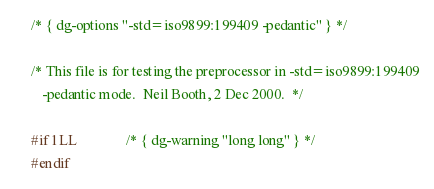Convert code to text. <code><loc_0><loc_0><loc_500><loc_500><_C_>/* { dg-options "-std=iso9899:199409 -pedantic" } */

/* This file is for testing the preprocessor in -std=iso9899:199409
   -pedantic mode.  Neil Booth, 2 Dec 2000.  */

#if 1LL				/* { dg-warning "long long" } */
#endif
</code> 